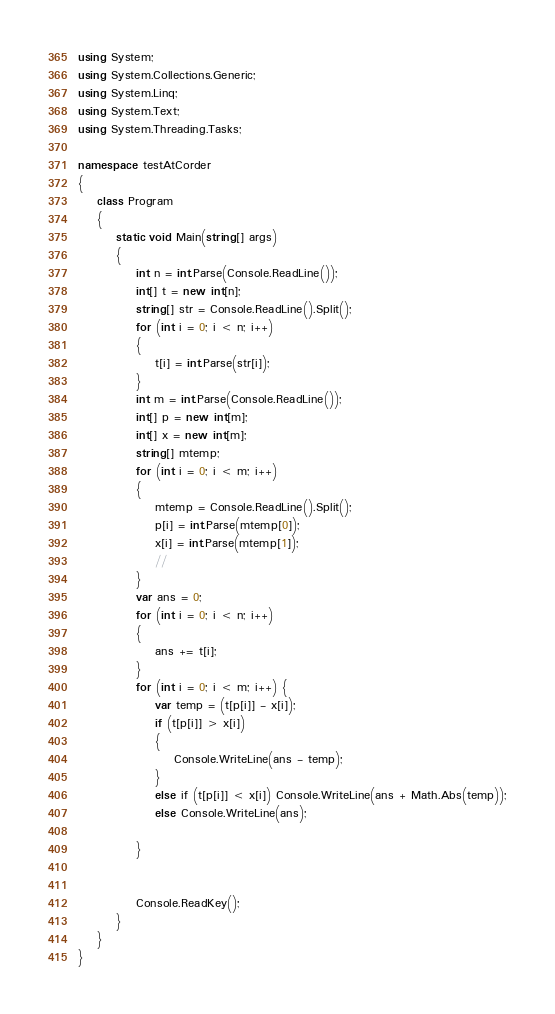<code> <loc_0><loc_0><loc_500><loc_500><_C#_>using System;
using System.Collections.Generic;
using System.Linq;
using System.Text;
using System.Threading.Tasks;

namespace testAtCorder
{
    class Program
    {
        static void Main(string[] args)
        {
            int n = int.Parse(Console.ReadLine());
            int[] t = new int[n];
            string[] str = Console.ReadLine().Split();
            for (int i = 0; i < n; i++)
            {
                t[i] = int.Parse(str[i]);
            }
            int m = int.Parse(Console.ReadLine());
            int[] p = new int[m];
            int[] x = new int[m];
            string[] mtemp;
            for (int i = 0; i < m; i++)
            {
                mtemp = Console.ReadLine().Split();
                p[i] = int.Parse(mtemp[0]);
                x[i] = int.Parse(mtemp[1]);
                //
            }
            var ans = 0;
            for (int i = 0; i < n; i++)
            {
                ans += t[i];
            }
            for (int i = 0; i < m; i++) {
                var temp = (t[p[i]] - x[i]);
                if (t[p[i]] > x[i])
                {
                    Console.WriteLine(ans - temp);
                }
                else if (t[p[i]] < x[i]) Console.WriteLine(ans + Math.Abs(temp));
                else Console.WriteLine(ans);
                
            }
            

            Console.ReadKey();
        }
    }
}
</code> 